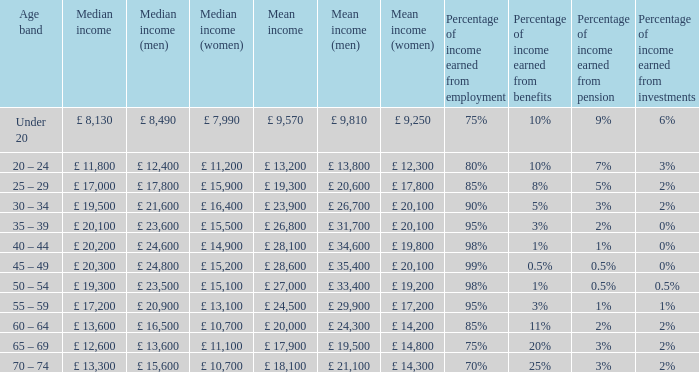Name the median income for age band being under 20 £ 8,130. 